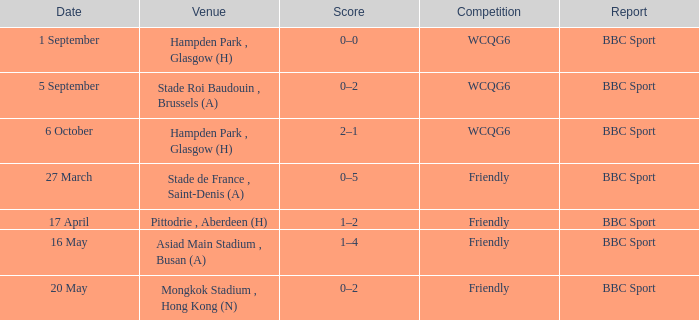Who reported the game on 6 october? BBC Sport. 